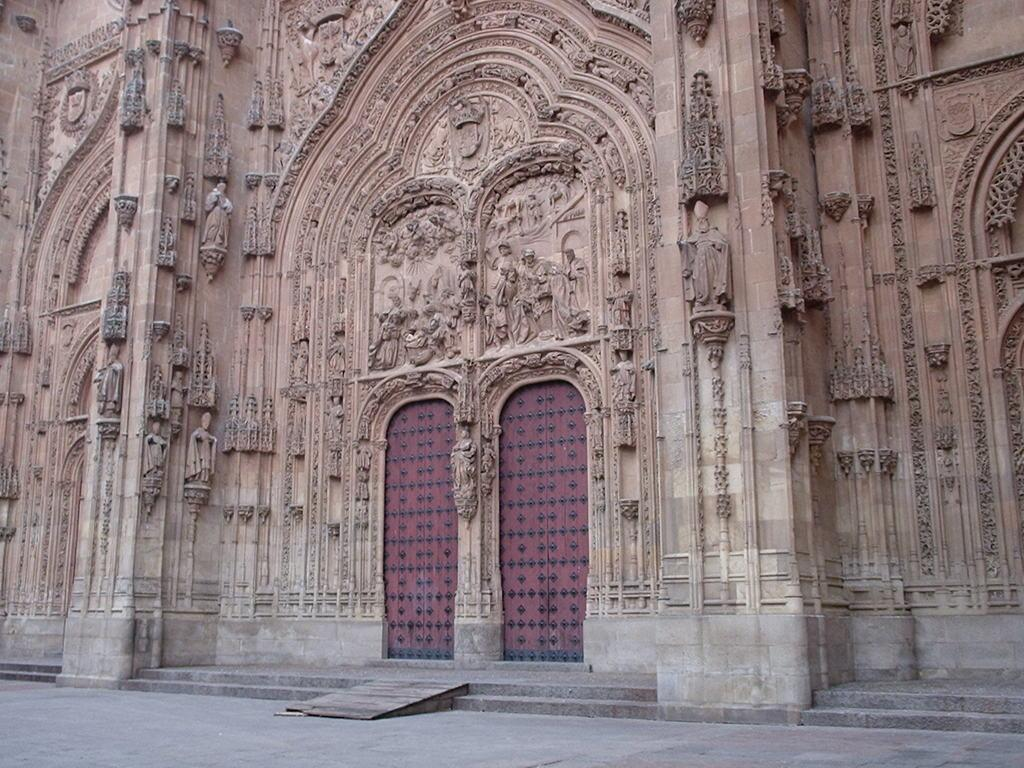What type of structure is present in the image? There is a building in the image. What features of the building are visible? The building has doors and steps. Are there any decorative elements on the building? Yes, there are sculptures on the walls of the building. What type of harmony is being represented by the trousers on the building? There are no trousers present on the building in the image. The sculptures on the walls are not trousers, and they do not represent any type of harmony. 